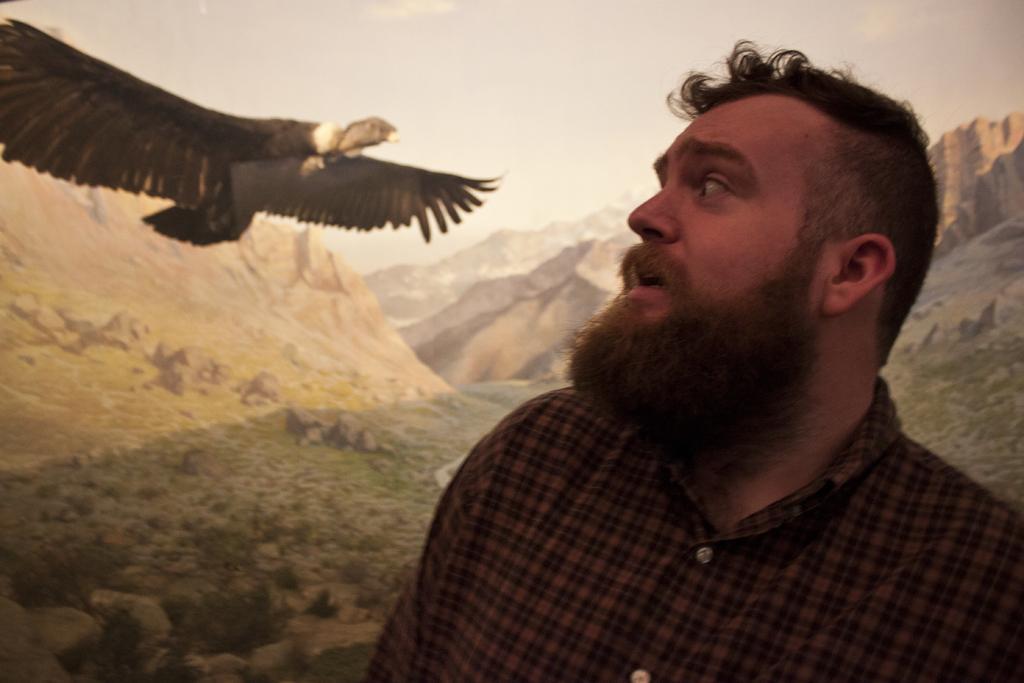In one or two sentences, can you explain what this image depicts? In this picture there is a man on the right side of the image and there is an eagle on the left side of the image, there is grassland in the background area of the image. 